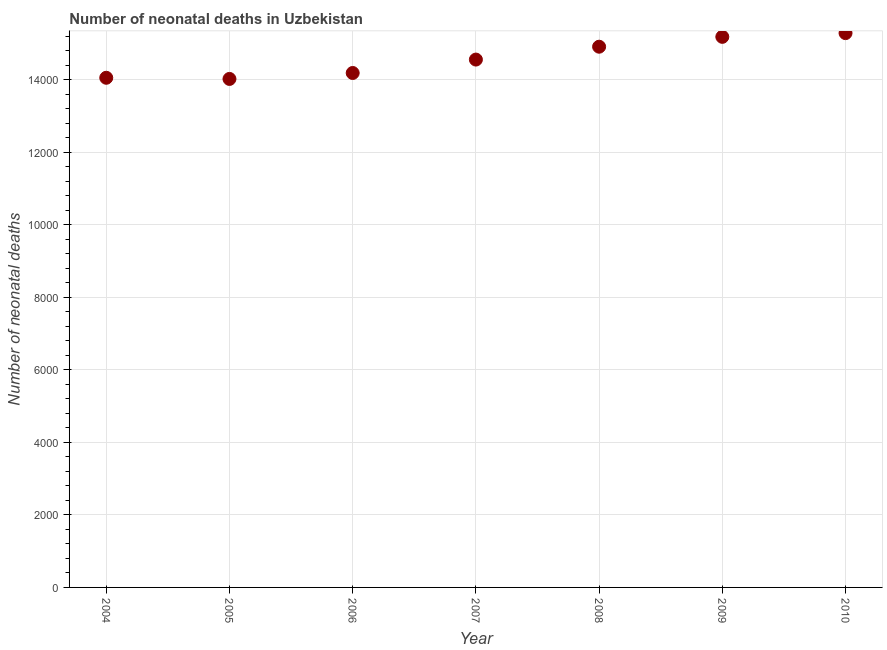What is the number of neonatal deaths in 2006?
Your response must be concise. 1.42e+04. Across all years, what is the maximum number of neonatal deaths?
Provide a succinct answer. 1.53e+04. Across all years, what is the minimum number of neonatal deaths?
Ensure brevity in your answer.  1.40e+04. In which year was the number of neonatal deaths maximum?
Provide a succinct answer. 2010. What is the sum of the number of neonatal deaths?
Ensure brevity in your answer.  1.02e+05. What is the difference between the number of neonatal deaths in 2004 and 2010?
Offer a very short reply. -1232. What is the average number of neonatal deaths per year?
Offer a terse response. 1.46e+04. What is the median number of neonatal deaths?
Ensure brevity in your answer.  1.46e+04. In how many years, is the number of neonatal deaths greater than 4800 ?
Keep it short and to the point. 7. Do a majority of the years between 2004 and 2006 (inclusive) have number of neonatal deaths greater than 4000 ?
Provide a succinct answer. Yes. What is the ratio of the number of neonatal deaths in 2004 to that in 2008?
Give a very brief answer. 0.94. Is the difference between the number of neonatal deaths in 2004 and 2007 greater than the difference between any two years?
Your response must be concise. No. What is the difference between the highest and the second highest number of neonatal deaths?
Offer a terse response. 103. Is the sum of the number of neonatal deaths in 2004 and 2008 greater than the maximum number of neonatal deaths across all years?
Your response must be concise. Yes. What is the difference between the highest and the lowest number of neonatal deaths?
Your answer should be compact. 1264. In how many years, is the number of neonatal deaths greater than the average number of neonatal deaths taken over all years?
Your answer should be compact. 3. How many years are there in the graph?
Offer a very short reply. 7. What is the difference between two consecutive major ticks on the Y-axis?
Offer a terse response. 2000. Does the graph contain any zero values?
Provide a succinct answer. No. What is the title of the graph?
Provide a succinct answer. Number of neonatal deaths in Uzbekistan. What is the label or title of the Y-axis?
Your answer should be very brief. Number of neonatal deaths. What is the Number of neonatal deaths in 2004?
Ensure brevity in your answer.  1.41e+04. What is the Number of neonatal deaths in 2005?
Your answer should be very brief. 1.40e+04. What is the Number of neonatal deaths in 2006?
Give a very brief answer. 1.42e+04. What is the Number of neonatal deaths in 2007?
Offer a very short reply. 1.46e+04. What is the Number of neonatal deaths in 2008?
Keep it short and to the point. 1.49e+04. What is the Number of neonatal deaths in 2009?
Ensure brevity in your answer.  1.52e+04. What is the Number of neonatal deaths in 2010?
Give a very brief answer. 1.53e+04. What is the difference between the Number of neonatal deaths in 2004 and 2005?
Your answer should be very brief. 32. What is the difference between the Number of neonatal deaths in 2004 and 2006?
Your answer should be very brief. -132. What is the difference between the Number of neonatal deaths in 2004 and 2007?
Provide a succinct answer. -502. What is the difference between the Number of neonatal deaths in 2004 and 2008?
Your answer should be compact. -857. What is the difference between the Number of neonatal deaths in 2004 and 2009?
Offer a terse response. -1129. What is the difference between the Number of neonatal deaths in 2004 and 2010?
Keep it short and to the point. -1232. What is the difference between the Number of neonatal deaths in 2005 and 2006?
Give a very brief answer. -164. What is the difference between the Number of neonatal deaths in 2005 and 2007?
Your answer should be compact. -534. What is the difference between the Number of neonatal deaths in 2005 and 2008?
Offer a very short reply. -889. What is the difference between the Number of neonatal deaths in 2005 and 2009?
Offer a very short reply. -1161. What is the difference between the Number of neonatal deaths in 2005 and 2010?
Keep it short and to the point. -1264. What is the difference between the Number of neonatal deaths in 2006 and 2007?
Ensure brevity in your answer.  -370. What is the difference between the Number of neonatal deaths in 2006 and 2008?
Give a very brief answer. -725. What is the difference between the Number of neonatal deaths in 2006 and 2009?
Provide a short and direct response. -997. What is the difference between the Number of neonatal deaths in 2006 and 2010?
Offer a very short reply. -1100. What is the difference between the Number of neonatal deaths in 2007 and 2008?
Provide a succinct answer. -355. What is the difference between the Number of neonatal deaths in 2007 and 2009?
Provide a short and direct response. -627. What is the difference between the Number of neonatal deaths in 2007 and 2010?
Offer a terse response. -730. What is the difference between the Number of neonatal deaths in 2008 and 2009?
Make the answer very short. -272. What is the difference between the Number of neonatal deaths in 2008 and 2010?
Your answer should be very brief. -375. What is the difference between the Number of neonatal deaths in 2009 and 2010?
Make the answer very short. -103. What is the ratio of the Number of neonatal deaths in 2004 to that in 2005?
Ensure brevity in your answer.  1. What is the ratio of the Number of neonatal deaths in 2004 to that in 2007?
Your answer should be very brief. 0.97. What is the ratio of the Number of neonatal deaths in 2004 to that in 2008?
Offer a terse response. 0.94. What is the ratio of the Number of neonatal deaths in 2004 to that in 2009?
Ensure brevity in your answer.  0.93. What is the ratio of the Number of neonatal deaths in 2004 to that in 2010?
Offer a very short reply. 0.92. What is the ratio of the Number of neonatal deaths in 2005 to that in 2006?
Offer a terse response. 0.99. What is the ratio of the Number of neonatal deaths in 2005 to that in 2007?
Offer a terse response. 0.96. What is the ratio of the Number of neonatal deaths in 2005 to that in 2009?
Give a very brief answer. 0.92. What is the ratio of the Number of neonatal deaths in 2005 to that in 2010?
Keep it short and to the point. 0.92. What is the ratio of the Number of neonatal deaths in 2006 to that in 2008?
Your response must be concise. 0.95. What is the ratio of the Number of neonatal deaths in 2006 to that in 2009?
Offer a very short reply. 0.93. What is the ratio of the Number of neonatal deaths in 2006 to that in 2010?
Provide a succinct answer. 0.93. What is the ratio of the Number of neonatal deaths in 2007 to that in 2009?
Your answer should be compact. 0.96. 